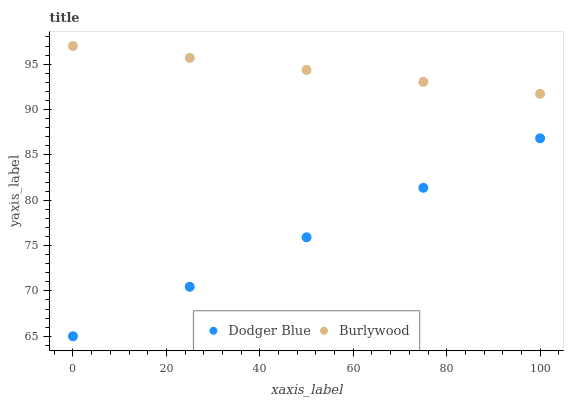Does Dodger Blue have the minimum area under the curve?
Answer yes or no. Yes. Does Burlywood have the maximum area under the curve?
Answer yes or no. Yes. Does Dodger Blue have the maximum area under the curve?
Answer yes or no. No. Is Burlywood the smoothest?
Answer yes or no. Yes. Is Dodger Blue the roughest?
Answer yes or no. Yes. Is Dodger Blue the smoothest?
Answer yes or no. No. Does Dodger Blue have the lowest value?
Answer yes or no. Yes. Does Burlywood have the highest value?
Answer yes or no. Yes. Does Dodger Blue have the highest value?
Answer yes or no. No. Is Dodger Blue less than Burlywood?
Answer yes or no. Yes. Is Burlywood greater than Dodger Blue?
Answer yes or no. Yes. Does Dodger Blue intersect Burlywood?
Answer yes or no. No. 